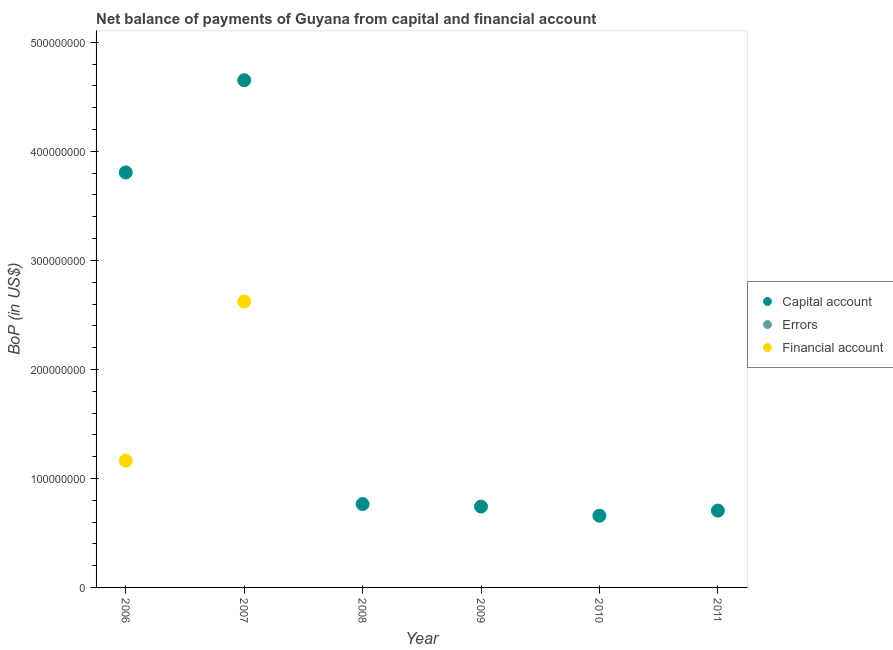Is the number of dotlines equal to the number of legend labels?
Keep it short and to the point. No. What is the amount of financial account in 2008?
Keep it short and to the point. 0. Across all years, what is the maximum amount of financial account?
Give a very brief answer. 2.62e+08. Across all years, what is the minimum amount of financial account?
Offer a terse response. 0. What is the total amount of financial account in the graph?
Give a very brief answer. 3.79e+08. What is the difference between the amount of net capital account in 2007 and that in 2011?
Offer a terse response. 3.95e+08. What is the difference between the amount of errors in 2007 and the amount of financial account in 2006?
Make the answer very short. -1.16e+08. What is the average amount of errors per year?
Your answer should be compact. 0. What is the ratio of the amount of net capital account in 2007 to that in 2011?
Provide a short and direct response. 6.6. What is the difference between the highest and the second highest amount of net capital account?
Your answer should be compact. 8.46e+07. What is the difference between the highest and the lowest amount of net capital account?
Make the answer very short. 4.00e+08. In how many years, is the amount of errors greater than the average amount of errors taken over all years?
Ensure brevity in your answer.  0. Is the sum of the amount of net capital account in 2006 and 2011 greater than the maximum amount of financial account across all years?
Your answer should be compact. Yes. Is it the case that in every year, the sum of the amount of net capital account and amount of errors is greater than the amount of financial account?
Give a very brief answer. Yes. Does the amount of errors monotonically increase over the years?
Make the answer very short. No. Is the amount of financial account strictly less than the amount of errors over the years?
Your answer should be compact. No. Where does the legend appear in the graph?
Make the answer very short. Center right. How many legend labels are there?
Your answer should be very brief. 3. How are the legend labels stacked?
Ensure brevity in your answer.  Vertical. What is the title of the graph?
Your answer should be very brief. Net balance of payments of Guyana from capital and financial account. Does "Ages 50+" appear as one of the legend labels in the graph?
Ensure brevity in your answer.  No. What is the label or title of the X-axis?
Your response must be concise. Year. What is the label or title of the Y-axis?
Your answer should be very brief. BoP (in US$). What is the BoP (in US$) of Capital account in 2006?
Ensure brevity in your answer.  3.81e+08. What is the BoP (in US$) of Financial account in 2006?
Your response must be concise. 1.16e+08. What is the BoP (in US$) in Capital account in 2007?
Your answer should be compact. 4.65e+08. What is the BoP (in US$) in Financial account in 2007?
Your response must be concise. 2.62e+08. What is the BoP (in US$) of Capital account in 2008?
Your answer should be compact. 7.65e+07. What is the BoP (in US$) of Errors in 2008?
Your response must be concise. 0. What is the BoP (in US$) in Capital account in 2009?
Your answer should be very brief. 7.42e+07. What is the BoP (in US$) of Errors in 2009?
Offer a very short reply. 0. What is the BoP (in US$) in Financial account in 2009?
Your answer should be compact. 0. What is the BoP (in US$) of Capital account in 2010?
Provide a succinct answer. 6.58e+07. What is the BoP (in US$) in Financial account in 2010?
Your answer should be very brief. 0. What is the BoP (in US$) in Capital account in 2011?
Offer a terse response. 7.05e+07. Across all years, what is the maximum BoP (in US$) of Capital account?
Give a very brief answer. 4.65e+08. Across all years, what is the maximum BoP (in US$) of Financial account?
Offer a terse response. 2.62e+08. Across all years, what is the minimum BoP (in US$) in Capital account?
Provide a succinct answer. 6.58e+07. What is the total BoP (in US$) in Capital account in the graph?
Offer a very short reply. 1.13e+09. What is the total BoP (in US$) of Errors in the graph?
Make the answer very short. 0. What is the total BoP (in US$) in Financial account in the graph?
Your answer should be compact. 3.79e+08. What is the difference between the BoP (in US$) in Capital account in 2006 and that in 2007?
Provide a succinct answer. -8.46e+07. What is the difference between the BoP (in US$) of Financial account in 2006 and that in 2007?
Your answer should be compact. -1.46e+08. What is the difference between the BoP (in US$) of Capital account in 2006 and that in 2008?
Make the answer very short. 3.04e+08. What is the difference between the BoP (in US$) of Capital account in 2006 and that in 2009?
Keep it short and to the point. 3.07e+08. What is the difference between the BoP (in US$) in Capital account in 2006 and that in 2010?
Offer a terse response. 3.15e+08. What is the difference between the BoP (in US$) in Capital account in 2006 and that in 2011?
Your answer should be compact. 3.10e+08. What is the difference between the BoP (in US$) in Capital account in 2007 and that in 2008?
Give a very brief answer. 3.89e+08. What is the difference between the BoP (in US$) of Capital account in 2007 and that in 2009?
Your response must be concise. 3.91e+08. What is the difference between the BoP (in US$) in Capital account in 2007 and that in 2010?
Give a very brief answer. 4.00e+08. What is the difference between the BoP (in US$) in Capital account in 2007 and that in 2011?
Keep it short and to the point. 3.95e+08. What is the difference between the BoP (in US$) of Capital account in 2008 and that in 2009?
Keep it short and to the point. 2.30e+06. What is the difference between the BoP (in US$) in Capital account in 2008 and that in 2010?
Your response must be concise. 1.07e+07. What is the difference between the BoP (in US$) in Capital account in 2008 and that in 2011?
Make the answer very short. 5.99e+06. What is the difference between the BoP (in US$) in Capital account in 2009 and that in 2010?
Ensure brevity in your answer.  8.40e+06. What is the difference between the BoP (in US$) in Capital account in 2009 and that in 2011?
Provide a short and direct response. 3.69e+06. What is the difference between the BoP (in US$) in Capital account in 2010 and that in 2011?
Keep it short and to the point. -4.70e+06. What is the difference between the BoP (in US$) of Capital account in 2006 and the BoP (in US$) of Financial account in 2007?
Provide a succinct answer. 1.18e+08. What is the average BoP (in US$) of Capital account per year?
Give a very brief answer. 1.89e+08. What is the average BoP (in US$) of Financial account per year?
Give a very brief answer. 6.31e+07. In the year 2006, what is the difference between the BoP (in US$) in Capital account and BoP (in US$) in Financial account?
Provide a short and direct response. 2.64e+08. In the year 2007, what is the difference between the BoP (in US$) of Capital account and BoP (in US$) of Financial account?
Provide a short and direct response. 2.03e+08. What is the ratio of the BoP (in US$) in Capital account in 2006 to that in 2007?
Make the answer very short. 0.82. What is the ratio of the BoP (in US$) of Financial account in 2006 to that in 2007?
Offer a terse response. 0.44. What is the ratio of the BoP (in US$) of Capital account in 2006 to that in 2008?
Provide a short and direct response. 4.98. What is the ratio of the BoP (in US$) in Capital account in 2006 to that in 2009?
Offer a terse response. 5.13. What is the ratio of the BoP (in US$) of Capital account in 2006 to that in 2010?
Your response must be concise. 5.79. What is the ratio of the BoP (in US$) in Capital account in 2006 to that in 2011?
Offer a terse response. 5.4. What is the ratio of the BoP (in US$) of Capital account in 2007 to that in 2008?
Your response must be concise. 6.08. What is the ratio of the BoP (in US$) of Capital account in 2007 to that in 2009?
Keep it short and to the point. 6.27. What is the ratio of the BoP (in US$) in Capital account in 2007 to that in 2010?
Keep it short and to the point. 7.07. What is the ratio of the BoP (in US$) of Capital account in 2007 to that in 2011?
Your answer should be very brief. 6.6. What is the ratio of the BoP (in US$) of Capital account in 2008 to that in 2009?
Make the answer very short. 1.03. What is the ratio of the BoP (in US$) in Capital account in 2008 to that in 2010?
Your answer should be compact. 1.16. What is the ratio of the BoP (in US$) of Capital account in 2008 to that in 2011?
Keep it short and to the point. 1.08. What is the ratio of the BoP (in US$) of Capital account in 2009 to that in 2010?
Give a very brief answer. 1.13. What is the ratio of the BoP (in US$) of Capital account in 2009 to that in 2011?
Your answer should be compact. 1.05. What is the ratio of the BoP (in US$) of Capital account in 2010 to that in 2011?
Your answer should be very brief. 0.93. What is the difference between the highest and the second highest BoP (in US$) in Capital account?
Your answer should be very brief. 8.46e+07. What is the difference between the highest and the lowest BoP (in US$) in Capital account?
Make the answer very short. 4.00e+08. What is the difference between the highest and the lowest BoP (in US$) in Financial account?
Make the answer very short. 2.62e+08. 